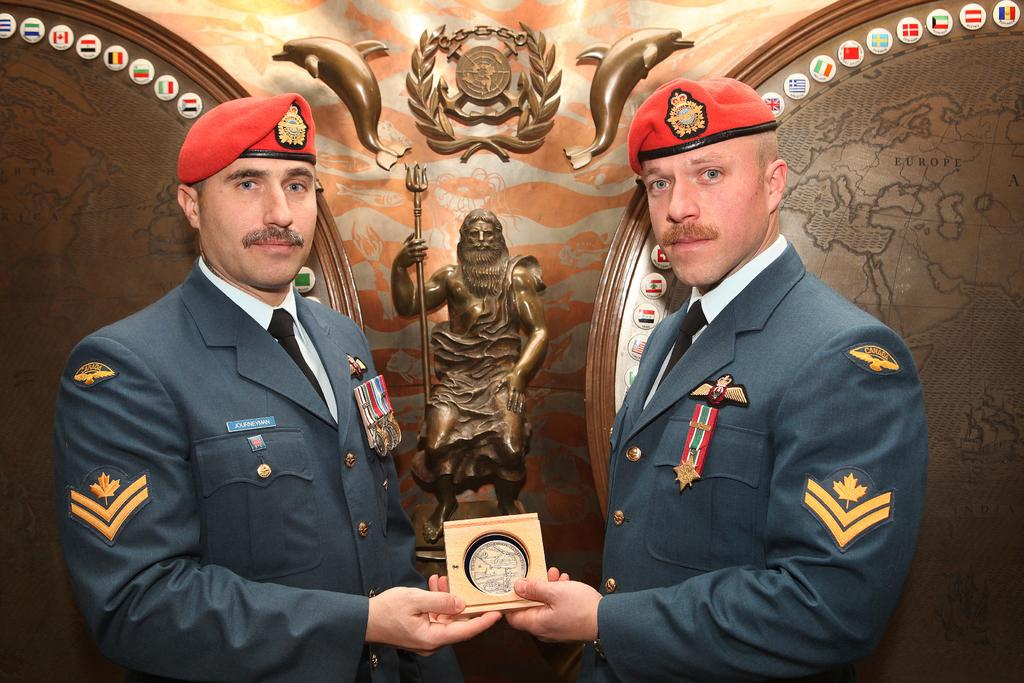How many people are in the image? There are two persons in the image. What are the persons wearing? The persons are wearing uniforms and red color caps. What are the persons holding in the image? The persons are holding an object. What position are the persons in? The persons are standing. What can be seen in the background of the image? There are sculptures in the background of the image. What type of milk can be seen in the image? There is no milk present in the image. How many eggs are visible in the image? There are no eggs visible in the image. 